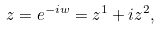<formula> <loc_0><loc_0><loc_500><loc_500>z = e ^ { - i w } = z ^ { 1 } + i z ^ { 2 } ,</formula> 